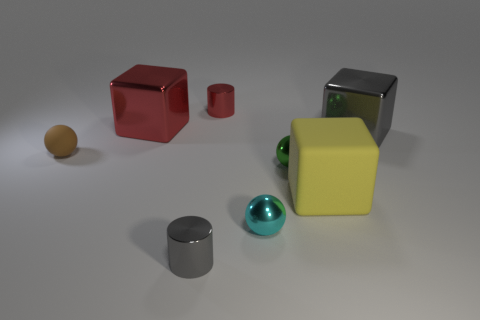Does the tiny metal object behind the green shiny object have the same shape as the gray metallic thing that is left of the green shiny sphere?
Your answer should be very brief. Yes. Are there the same number of small metallic objects behind the small red metallic thing and large gray shiny things?
Provide a succinct answer. No. There is a block on the left side of the cyan shiny thing; is there a metallic block in front of it?
Make the answer very short. Yes. Is there anything else of the same color as the large matte block?
Provide a succinct answer. No. Do the large object that is on the left side of the small red object and the cyan object have the same material?
Your answer should be compact. Yes. Are there an equal number of small brown balls behind the large red metal cube and blocks that are right of the gray cylinder?
Keep it short and to the point. No. There is a gray thing in front of the gray object that is behind the yellow object; what size is it?
Provide a short and direct response. Small. The ball that is to the left of the tiny green sphere and to the right of the tiny red thing is made of what material?
Make the answer very short. Metal. How many other objects are there of the same size as the red cube?
Your answer should be compact. 2. What is the color of the tiny matte ball?
Ensure brevity in your answer.  Brown. 